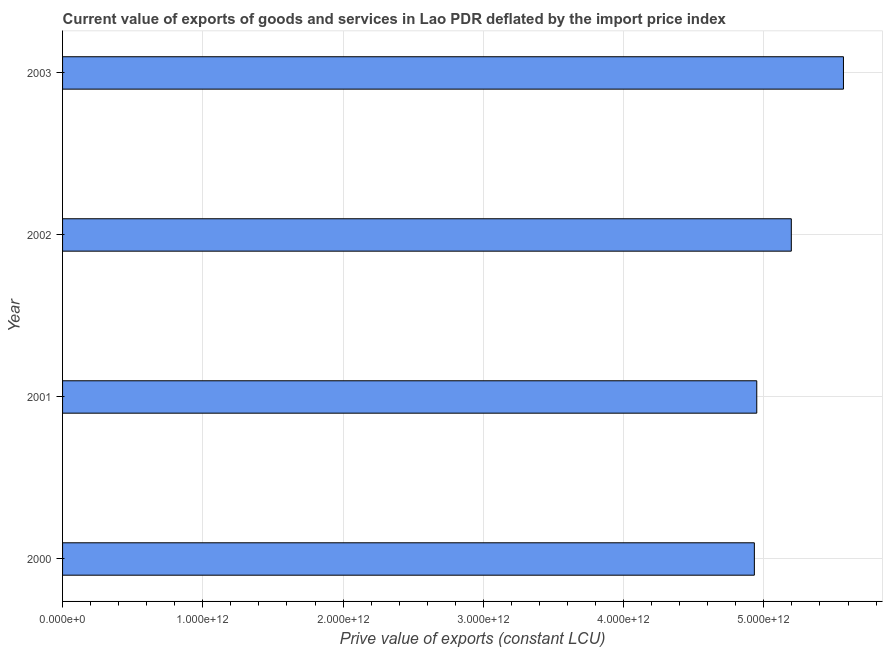What is the title of the graph?
Ensure brevity in your answer.  Current value of exports of goods and services in Lao PDR deflated by the import price index. What is the label or title of the X-axis?
Your answer should be very brief. Prive value of exports (constant LCU). What is the price value of exports in 2002?
Ensure brevity in your answer.  5.20e+12. Across all years, what is the maximum price value of exports?
Your response must be concise. 5.57e+12. Across all years, what is the minimum price value of exports?
Offer a very short reply. 4.93e+12. What is the sum of the price value of exports?
Provide a short and direct response. 2.06e+13. What is the difference between the price value of exports in 2001 and 2002?
Offer a terse response. -2.46e+11. What is the average price value of exports per year?
Offer a terse response. 5.16e+12. What is the median price value of exports?
Provide a succinct answer. 5.07e+12. In how many years, is the price value of exports greater than 3600000000000 LCU?
Provide a succinct answer. 4. Do a majority of the years between 2003 and 2000 (inclusive) have price value of exports greater than 1600000000000 LCU?
Provide a succinct answer. Yes. What is the ratio of the price value of exports in 2000 to that in 2001?
Provide a short and direct response. 1. Is the difference between the price value of exports in 2001 and 2003 greater than the difference between any two years?
Your answer should be very brief. No. What is the difference between the highest and the second highest price value of exports?
Your answer should be compact. 3.72e+11. What is the difference between the highest and the lowest price value of exports?
Your answer should be very brief. 6.35e+11. How many years are there in the graph?
Make the answer very short. 4. What is the difference between two consecutive major ticks on the X-axis?
Offer a very short reply. 1.00e+12. What is the Prive value of exports (constant LCU) in 2000?
Your answer should be very brief. 4.93e+12. What is the Prive value of exports (constant LCU) of 2001?
Offer a terse response. 4.95e+12. What is the Prive value of exports (constant LCU) in 2002?
Your response must be concise. 5.20e+12. What is the Prive value of exports (constant LCU) in 2003?
Offer a terse response. 5.57e+12. What is the difference between the Prive value of exports (constant LCU) in 2000 and 2001?
Provide a short and direct response. -1.71e+1. What is the difference between the Prive value of exports (constant LCU) in 2000 and 2002?
Offer a very short reply. -2.63e+11. What is the difference between the Prive value of exports (constant LCU) in 2000 and 2003?
Provide a succinct answer. -6.35e+11. What is the difference between the Prive value of exports (constant LCU) in 2001 and 2002?
Your answer should be very brief. -2.46e+11. What is the difference between the Prive value of exports (constant LCU) in 2001 and 2003?
Your answer should be very brief. -6.18e+11. What is the difference between the Prive value of exports (constant LCU) in 2002 and 2003?
Make the answer very short. -3.72e+11. What is the ratio of the Prive value of exports (constant LCU) in 2000 to that in 2002?
Provide a succinct answer. 0.95. What is the ratio of the Prive value of exports (constant LCU) in 2000 to that in 2003?
Offer a terse response. 0.89. What is the ratio of the Prive value of exports (constant LCU) in 2001 to that in 2002?
Your answer should be very brief. 0.95. What is the ratio of the Prive value of exports (constant LCU) in 2001 to that in 2003?
Provide a short and direct response. 0.89. What is the ratio of the Prive value of exports (constant LCU) in 2002 to that in 2003?
Keep it short and to the point. 0.93. 